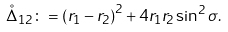Convert formula to latex. <formula><loc_0><loc_0><loc_500><loc_500>\mathring { \Delta } _ { 1 2 } \colon = \left ( r _ { 1 } - r _ { 2 } \right ) ^ { 2 } + 4 r _ { 1 } r _ { 2 } \sin ^ { 2 } \sigma .</formula> 